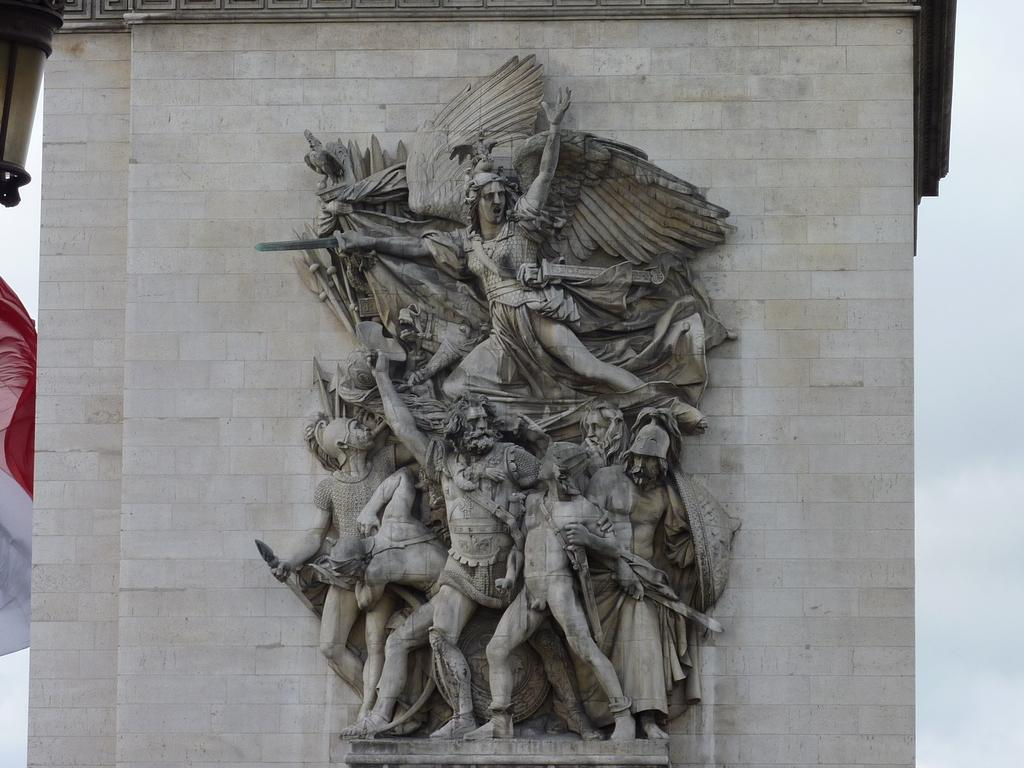What is the main subject in the center of the image? There are sculptures in the center of the image. Where are the sculptures located? The sculptures are on a wall. What is the condition of the sky in the image? The sky is cloudy in the image. What type of organization is depicted in the sculptures? The sculptures do not depict any organization; they are simply sculptures on a wall. Can you see the moon in the image? There is no moon visible in the image; only the cloudy sky is mentioned. 